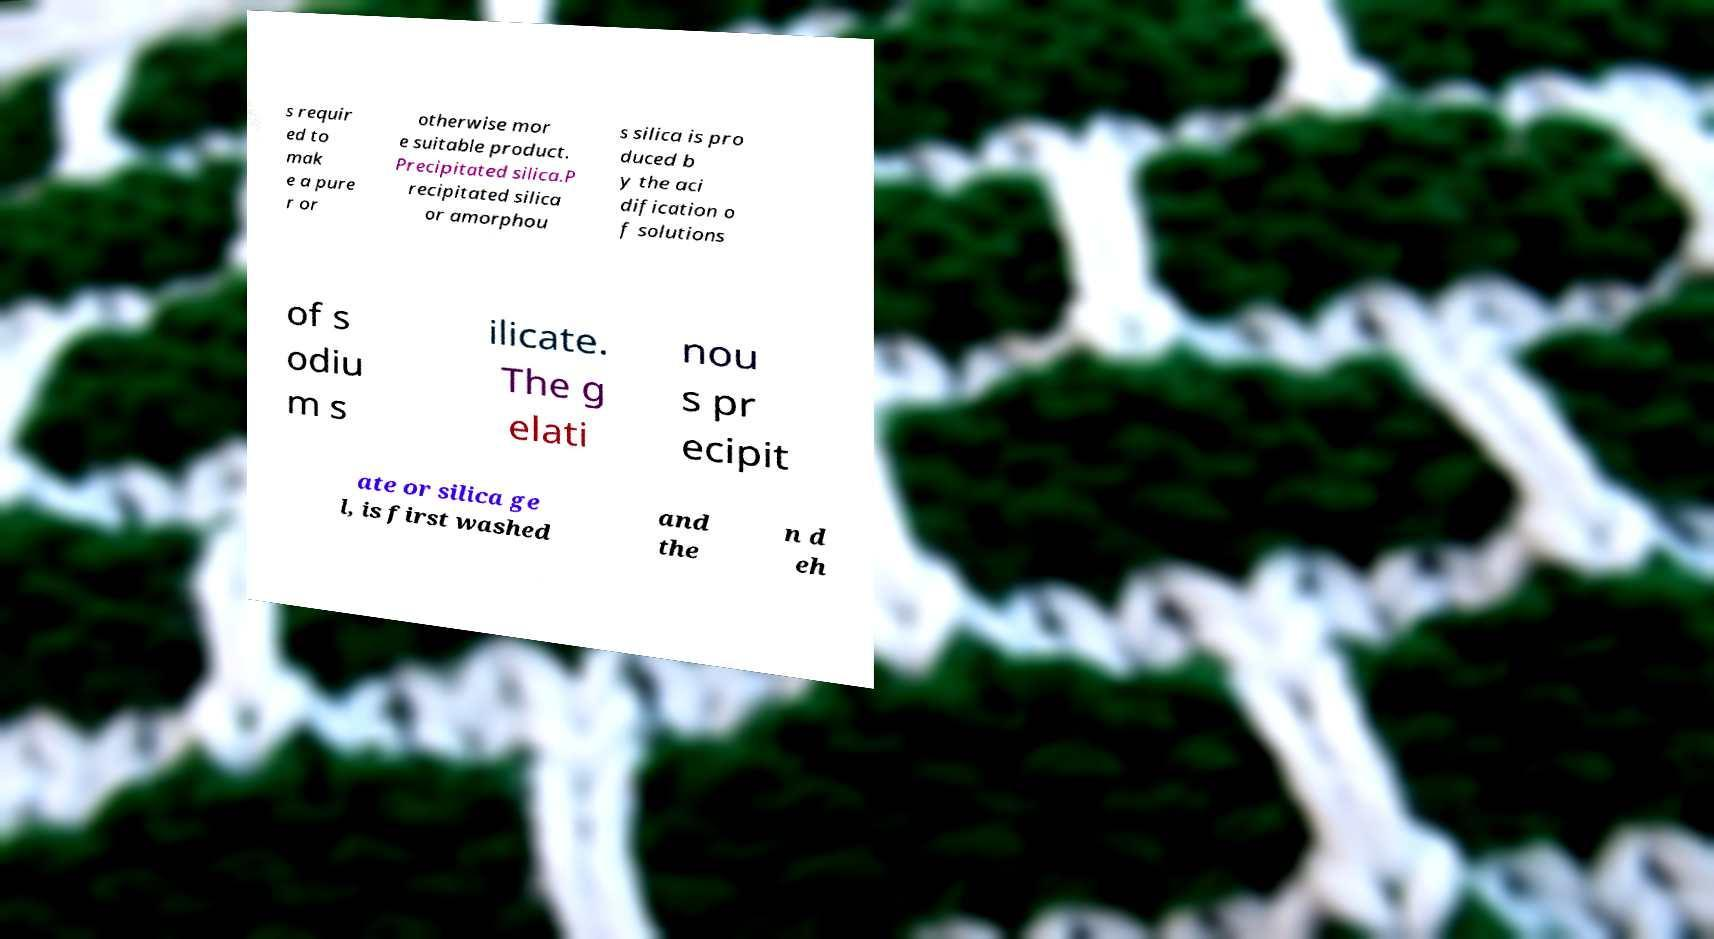What messages or text are displayed in this image? I need them in a readable, typed format. s requir ed to mak e a pure r or otherwise mor e suitable product. Precipitated silica.P recipitated silica or amorphou s silica is pro duced b y the aci dification o f solutions of s odiu m s ilicate. The g elati nou s pr ecipit ate or silica ge l, is first washed and the n d eh 